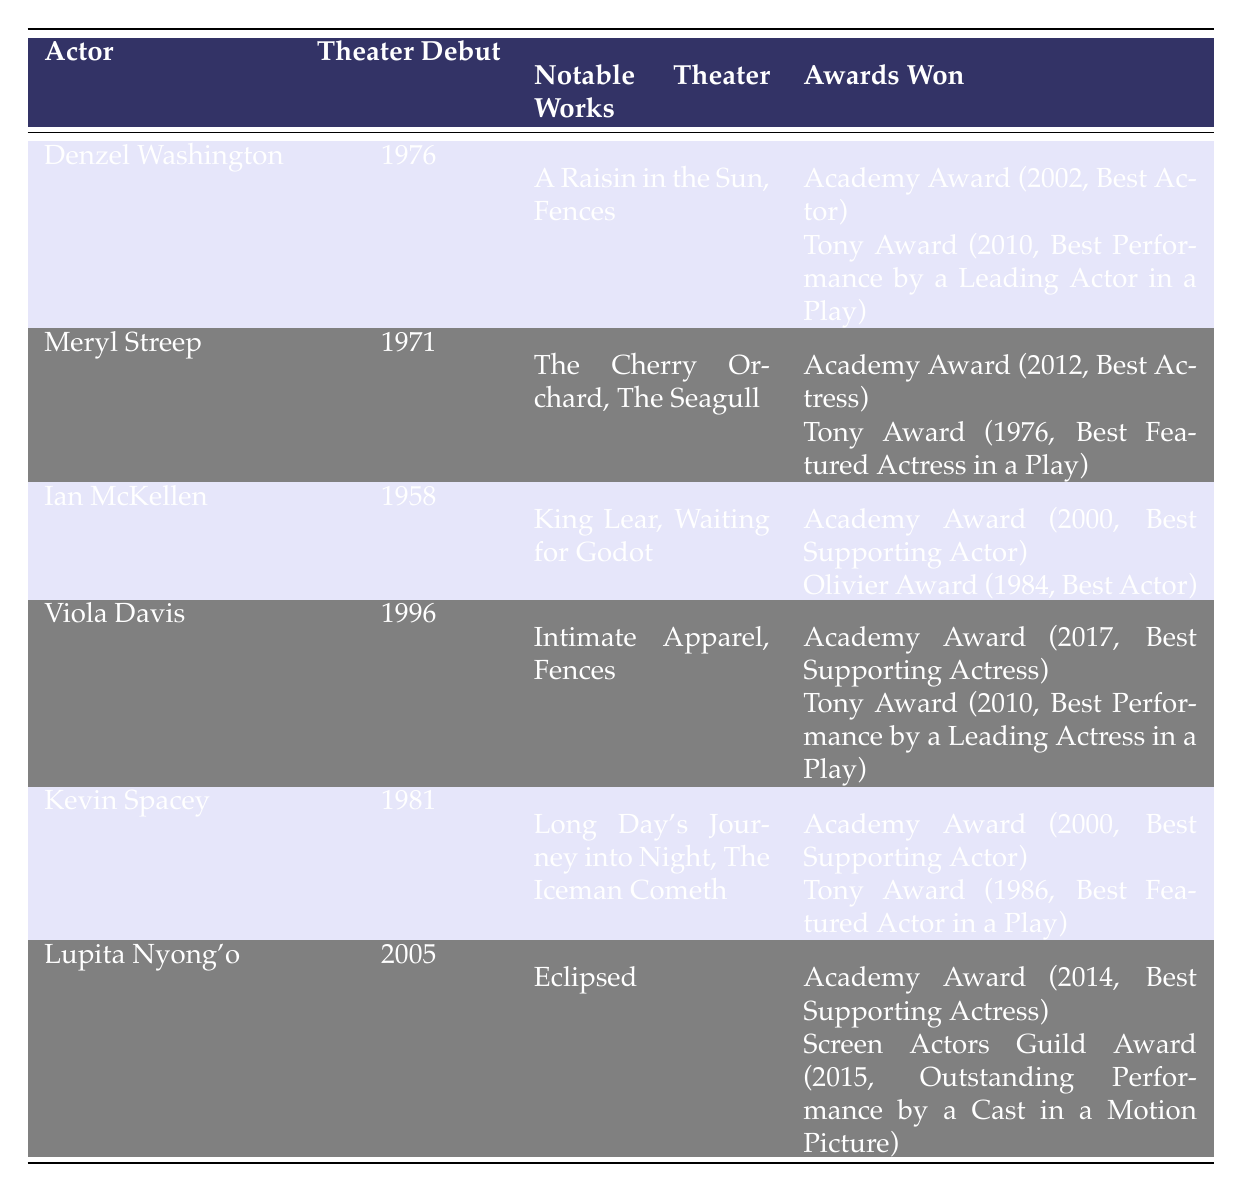What year did Denzel Washington make his theater debut? Denzel Washington's theater debut year is listed in the table under "Theater Debut," which shows 1976.
Answer: 1976 How many Academy Awards has Meryl Streep won according to the table? The table indicates that Meryl Streep has won one Academy Award, which is listed as received in 2012.
Answer: One Which actor has the earliest theater debut year? By comparing the theater debut years listed for all actors, Ian McKellen has the earliest debut year in 1958.
Answer: Ian McKellen What notable theater work is associated with Viola Davis? The table lists "Intimate Apparel" and "Fences" as notable theater works for Viola Davis, which can be directly seen under that column.
Answer: Intimate Apparel, Fences Did Kevin Spacey win a Tony Award and an Academy Award in the same year? The table shows Kevin Spacey winning the Academy Award in 2000 and the Tony Award in 1986, indicating that he did not win both in the same year.
Answer: No What is the total number of Tony Awards won by the actors listed in the table? By counting the Tony Awards in the "Awards Won" section for each actor: Denzel Washington (1), Meryl Streep (1), Viola Davis (1), Kevin Spacey (1) gives a total of 4.
Answer: 4 Which award category did Lupita Nyong'o win an Academy Award for? The table states that Lupita Nyong'o won the Academy Award for "Best Supporting Actress," which is noted in her awards section.
Answer: Best Supporting Actress Who are the actors that have both Tony and Academy Awards listed in the table? The actors with both awards are Denzel Washington, Meryl Streep, Viola Davis, and Kevin Spacey, as indicated in their awards sections.
Answer: Denzel Washington, Meryl Streep, Viola Davis, Kevin Spacey Which actor started their theater career most recently? Among the debut years, Lupita Nyong'o has the most recent start year, which is 2005, as listed in the table.
Answer: Lupita Nyong'o What is the average year of theater debuts among the actors? The theater debut years are: 1976, 1971, 1958, 1996, 1981, 2005. Adding them up gives 1976 + 1971 + 1958 + 1996 + 1981 + 2005 = 11947. Dividing by the number of actors (6) results in an average year of approximately 1991.
Answer: 1991 